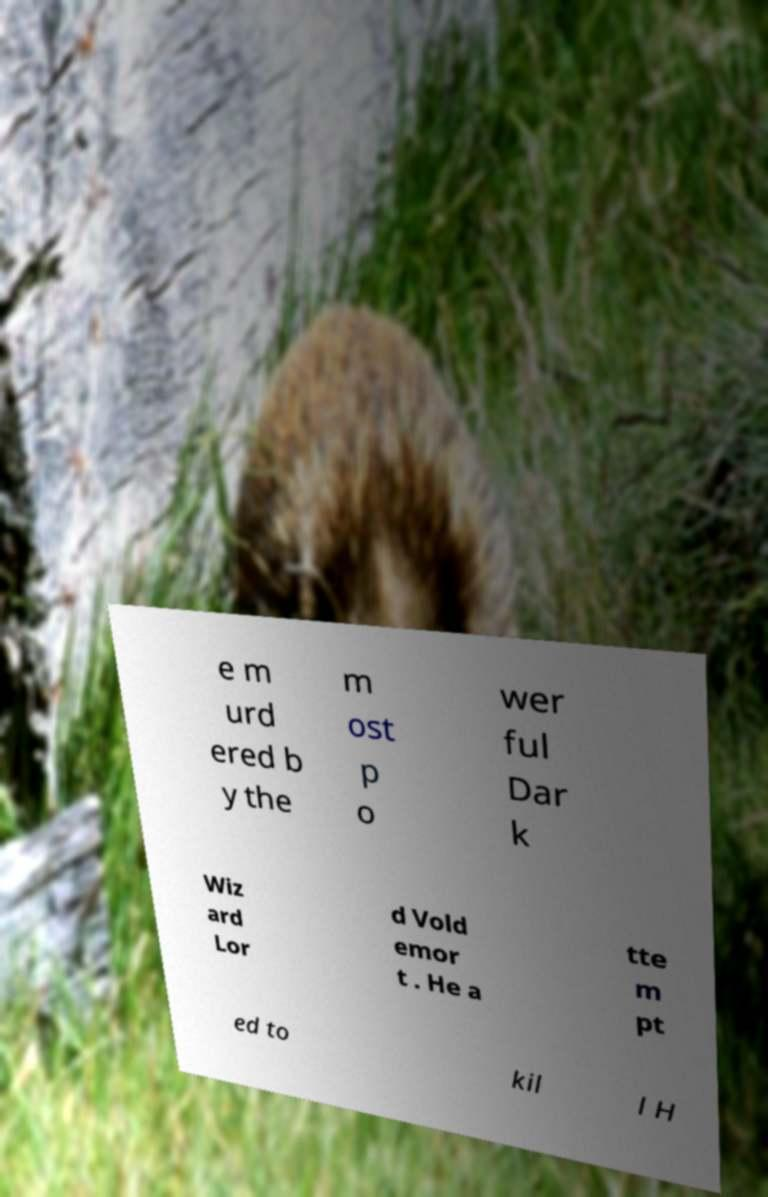I need the written content from this picture converted into text. Can you do that? e m urd ered b y the m ost p o wer ful Dar k Wiz ard Lor d Vold emor t . He a tte m pt ed to kil l H 